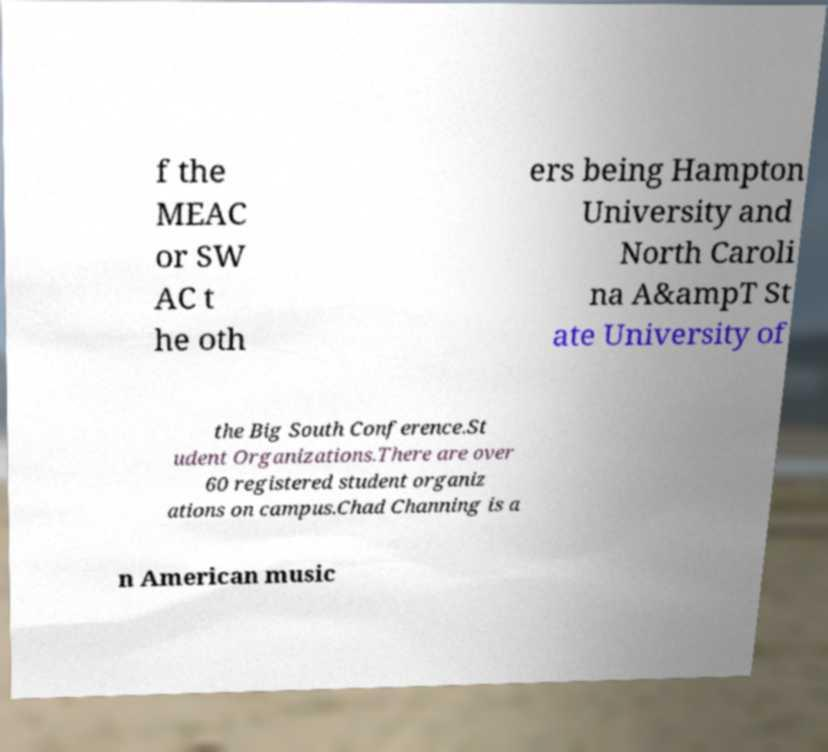Please read and relay the text visible in this image. What does it say? f the MEAC or SW AC t he oth ers being Hampton University and North Caroli na A&ampT St ate University of the Big South Conference.St udent Organizations.There are over 60 registered student organiz ations on campus.Chad Channing is a n American music 